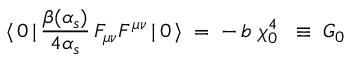Convert formula to latex. <formula><loc_0><loc_0><loc_500><loc_500>\langle \, 0 \, | \, \frac { \beta ( \alpha _ { s } ) } { 4 \alpha _ { s } } \, F _ { \mu \nu } F ^ { \mu \nu } \, | \, 0 \, \rangle \, = \, - \, b \, \chi _ { 0 } ^ { 4 } \, \equiv \, G _ { 0 }</formula> 